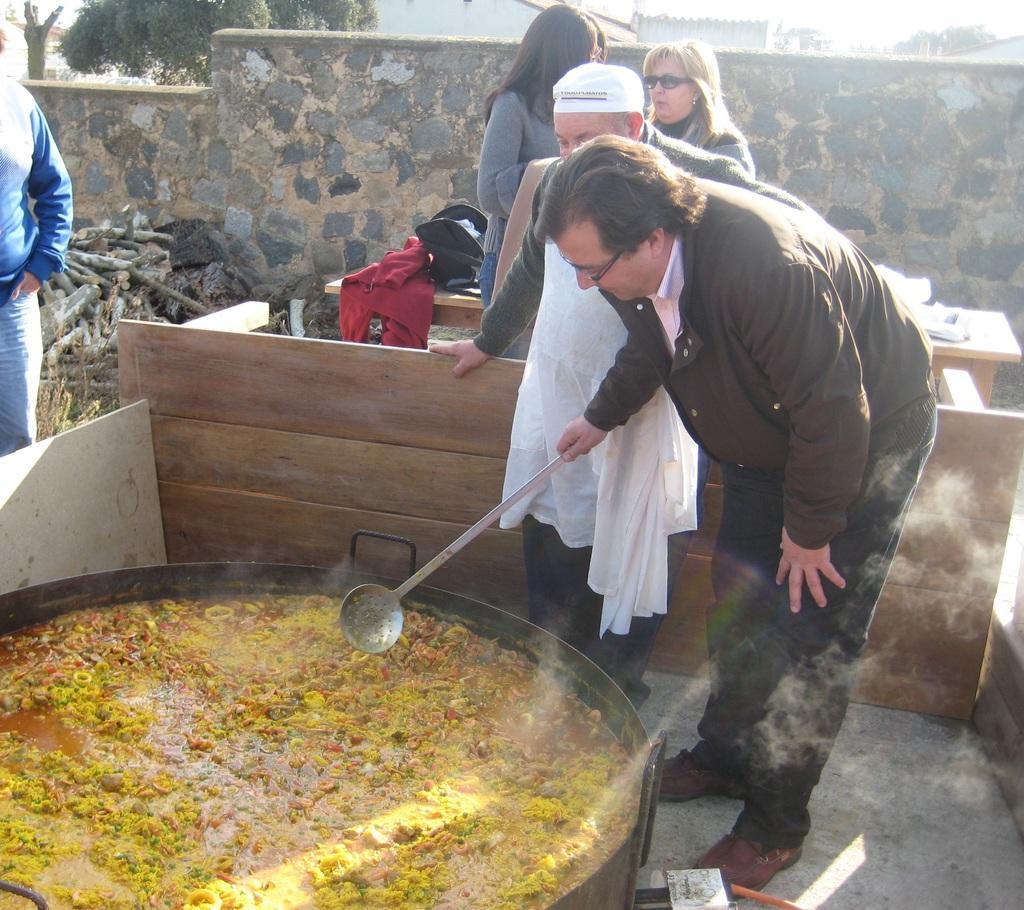Can you describe this image briefly? In this image we can see a few people, one of them is holding a spoon, there is a food item in the bowl, there are tables, there are bags on one table, there are plants, buildings, also we can see the wall. 